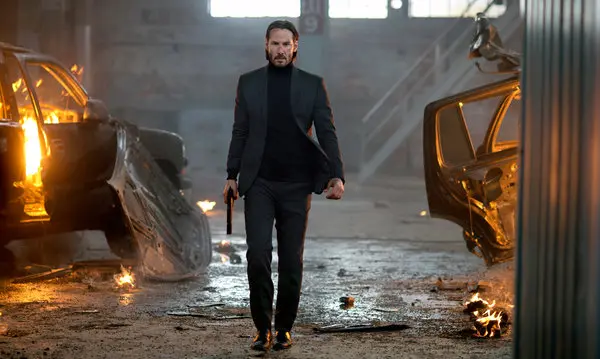If this scene were part of a movie, what do you think happened just before this moment? Just before this moment, the character likely survived a fierce gunfight or car chase that resulted in the fiery destruction seen around him. He might have narrowly escaped an ambush, taking down several adversaries in the process. The scene portrays the aftermath of this intense struggle, where he gathers himself to continue his relentless pursuit of a key target or to rescue someone important. The burning vehicles and scattered debris set the stage for the high-stakes, adrenaline-pumping continuation of his mission. 